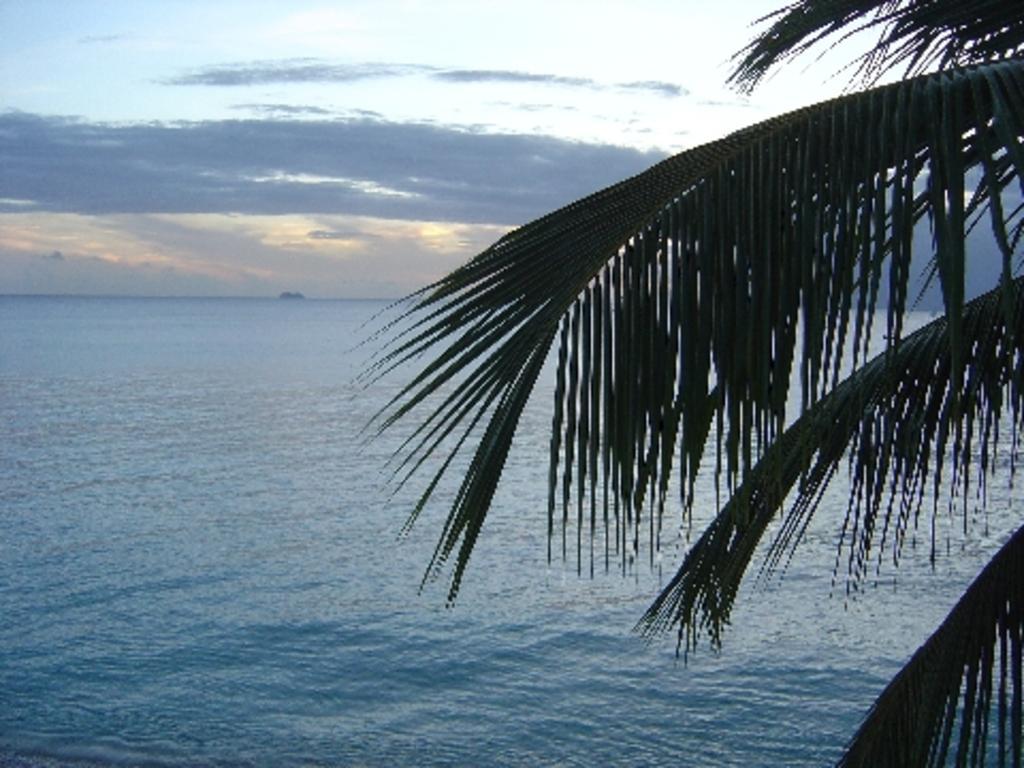In one or two sentences, can you explain what this image depicts? In this image, this looks like a sea with the water flowing. On the right side of the image, I can see a tree with the leaves. These are the clouds in the sky. 